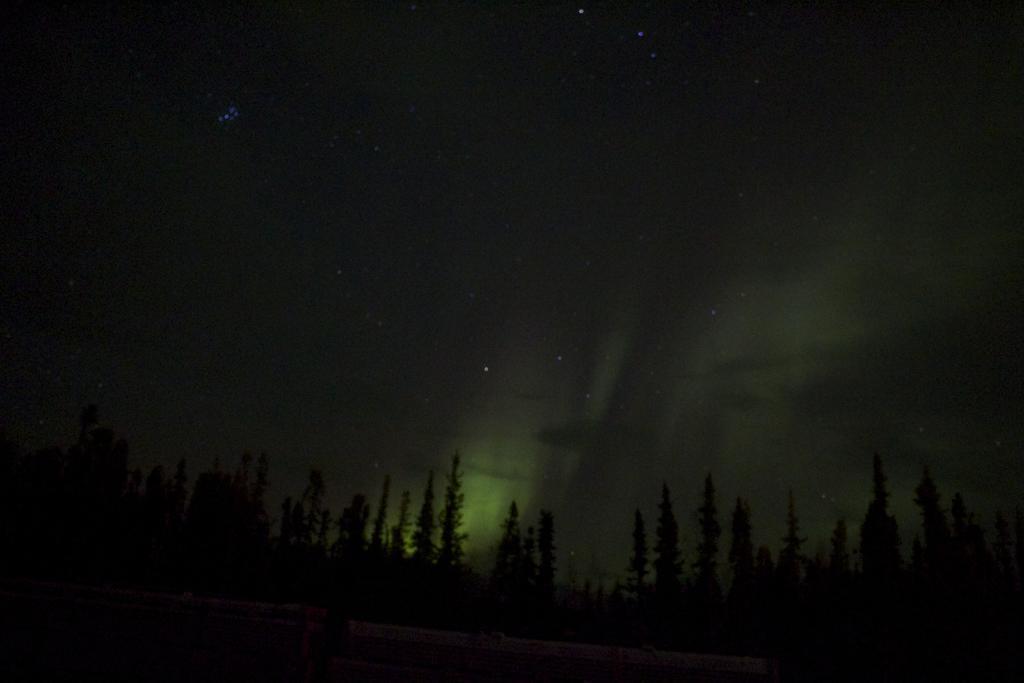Describe this image in one or two sentences. In this image we can see a group of trees. We can also see the sky with some stars. 